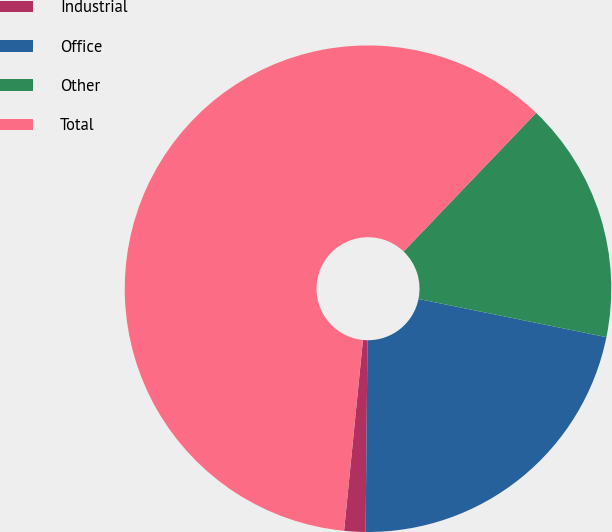<chart> <loc_0><loc_0><loc_500><loc_500><pie_chart><fcel>Industrial<fcel>Office<fcel>Other<fcel>Total<nl><fcel>1.41%<fcel>21.97%<fcel>16.05%<fcel>60.58%<nl></chart> 